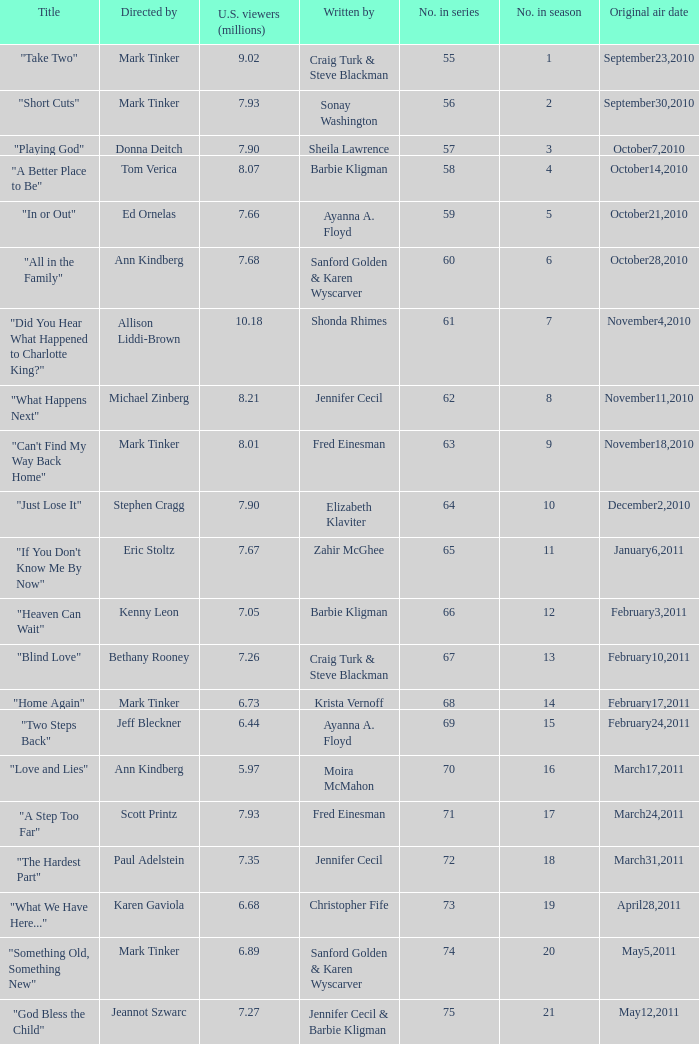What number episode in the season was directed by Paul Adelstein?  18.0. 